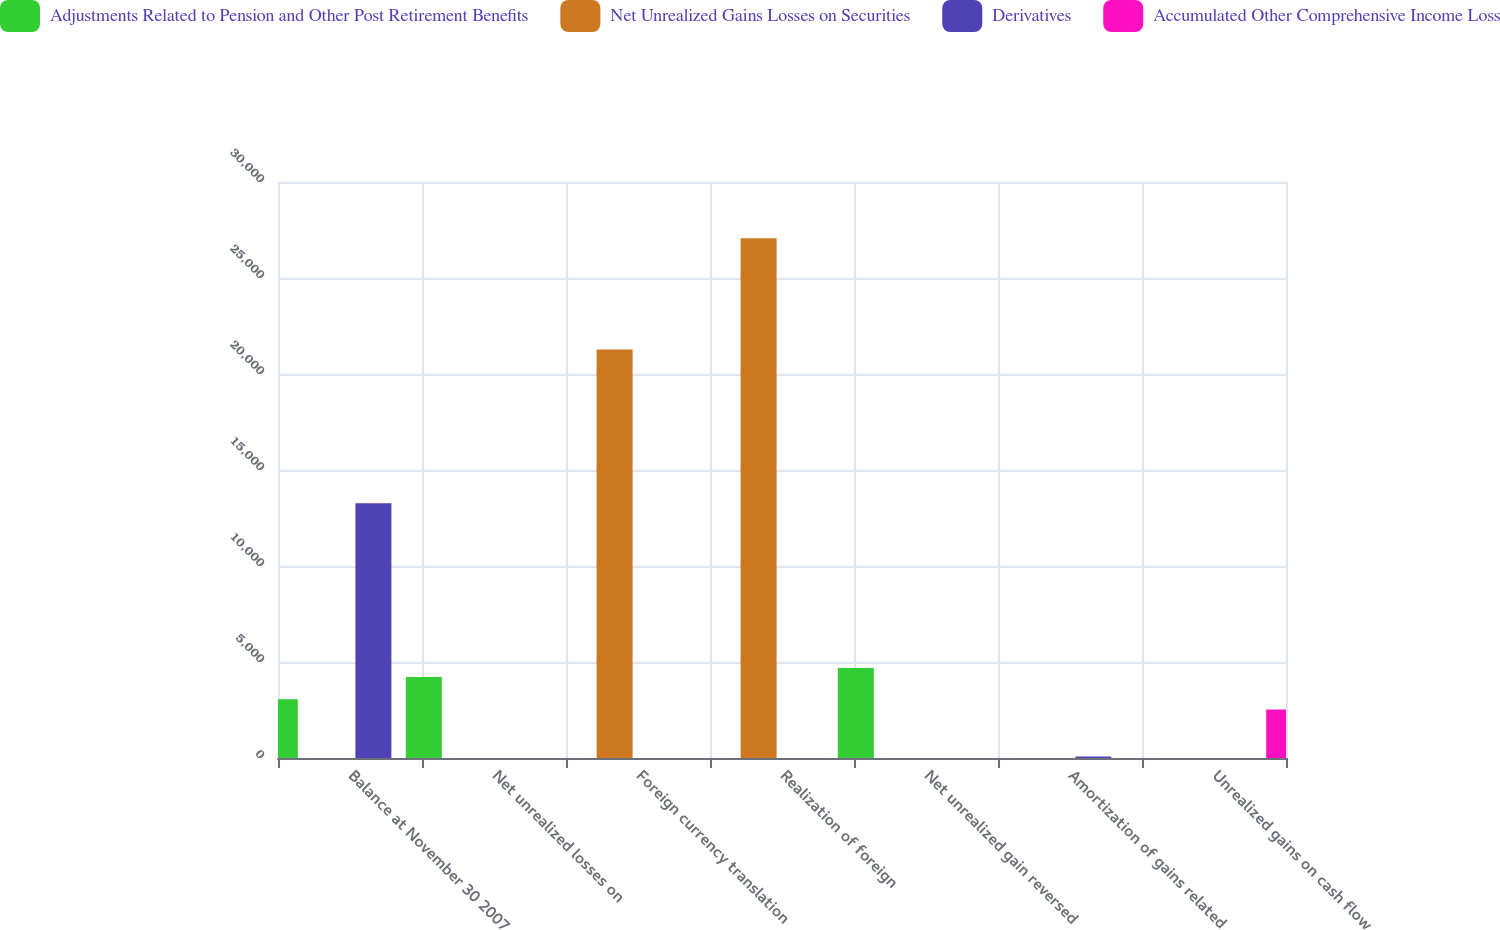Convert chart to OTSL. <chart><loc_0><loc_0><loc_500><loc_500><stacked_bar_chart><ecel><fcel>Balance at November 30 2007<fcel>Net unrealized losses on<fcel>Foreign currency translation<fcel>Realization of foreign<fcel>Net unrealized gain reversed<fcel>Amortization of gains related<fcel>Unrealized gains on cash flow<nl><fcel>Adjustments Related to Pension and Other Post Retirement Benefits<fcel>3061<fcel>4213<fcel>0<fcel>0<fcel>4681<fcel>0<fcel>0<nl><fcel>Net Unrealized Gains Losses on Securities<fcel>0<fcel>0<fcel>21282<fcel>27076<fcel>0<fcel>0<fcel>0<nl><fcel>Derivatives<fcel>13265<fcel>0<fcel>0<fcel>0<fcel>0<fcel>78<fcel>0<nl><fcel>Accumulated Other Comprehensive Income Loss<fcel>0<fcel>0<fcel>0<fcel>0<fcel>0<fcel>0<fcel>2525<nl></chart> 